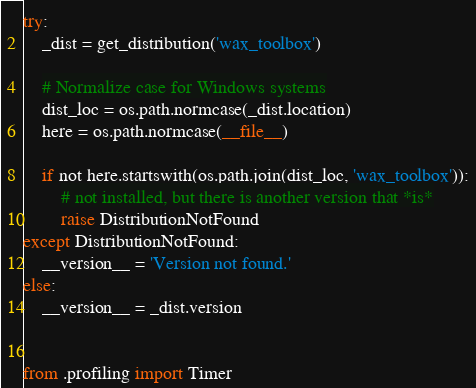<code> <loc_0><loc_0><loc_500><loc_500><_Python_>try:
    _dist = get_distribution('wax_toolbox')

    # Normalize case for Windows systems
    dist_loc = os.path.normcase(_dist.location)
    here = os.path.normcase(__file__)

    if not here.startswith(os.path.join(dist_loc, 'wax_toolbox')):
        # not installed, but there is another version that *is*
        raise DistributionNotFound
except DistributionNotFound:
    __version__ = 'Version not found.'
else:
    __version__ = _dist.version


from .profiling import Timer
</code> 